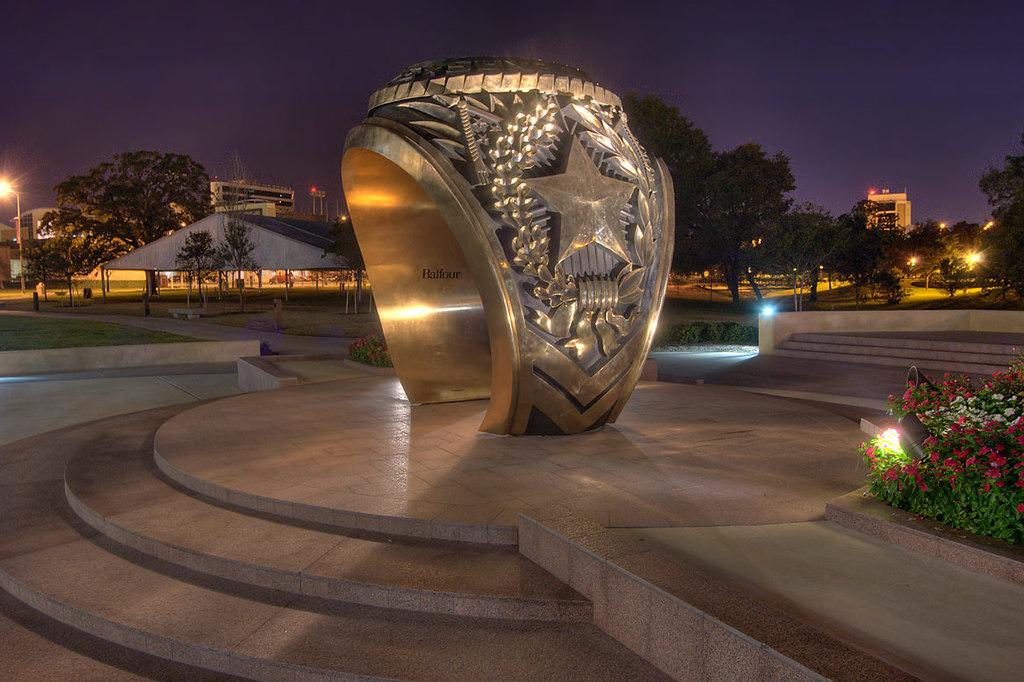What is the main subject of the image? There is a ring statue in the image. What can be seen in the background of the image? There are trees and buildings in the background of the image. What is the color of the trees in the image? The trees are green in color. What type of structures are present in the image? Light poles and stairs are present in the image. What is the color of the sky in the image? The sky is blue in color. Can you tell me how many snails are crawling on the ring statue in the image? There are no snails present on the ring statue in the image. What type of crime is being committed in the image? There is no crime depicted in the image; it features a ring statue, trees, buildings, light poles, stairs, and a blue sky. 